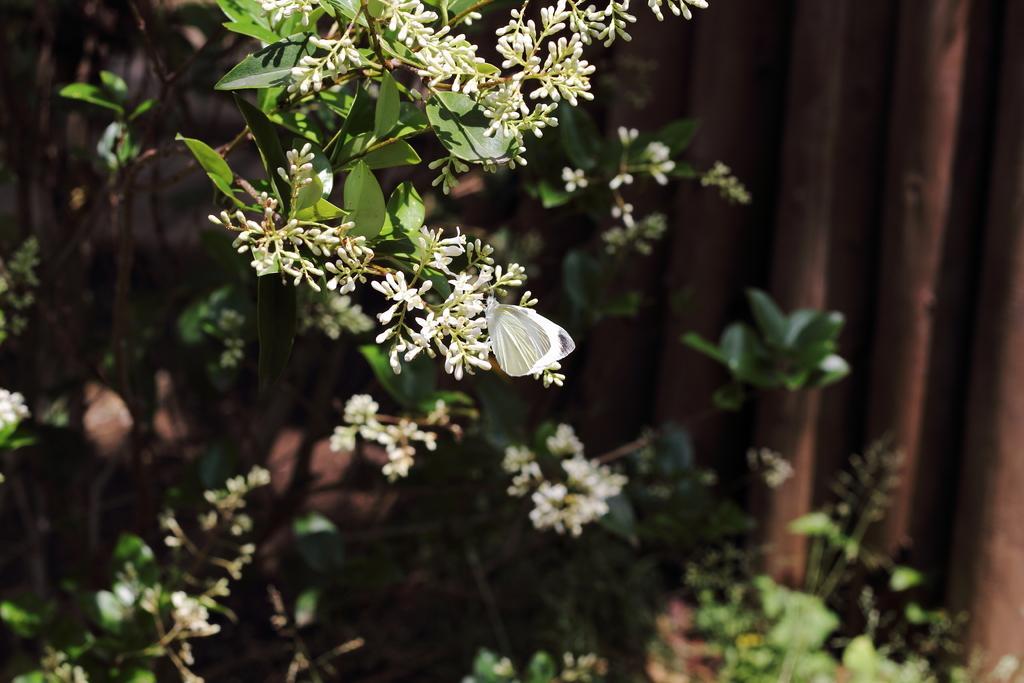In one or two sentences, can you explain what this image depicts? In this image we can see some plants which has flowers. 